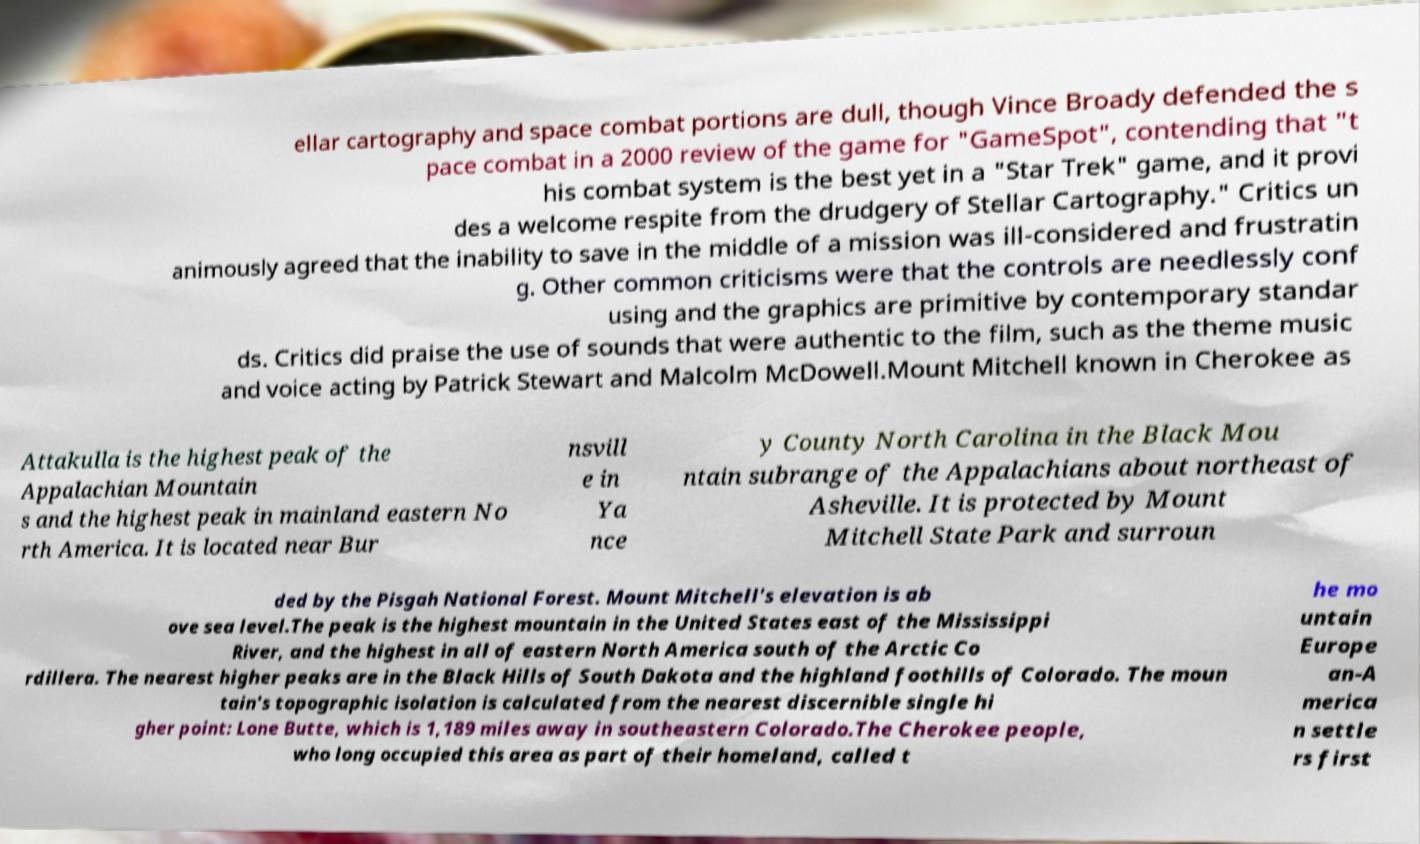Can you accurately transcribe the text from the provided image for me? ellar cartography and space combat portions are dull, though Vince Broady defended the s pace combat in a 2000 review of the game for "GameSpot", contending that "t his combat system is the best yet in a "Star Trek" game, and it provi des a welcome respite from the drudgery of Stellar Cartography." Critics un animously agreed that the inability to save in the middle of a mission was ill-considered and frustratin g. Other common criticisms were that the controls are needlessly conf using and the graphics are primitive by contemporary standar ds. Critics did praise the use of sounds that were authentic to the film, such as the theme music and voice acting by Patrick Stewart and Malcolm McDowell.Mount Mitchell known in Cherokee as Attakulla is the highest peak of the Appalachian Mountain s and the highest peak in mainland eastern No rth America. It is located near Bur nsvill e in Ya nce y County North Carolina in the Black Mou ntain subrange of the Appalachians about northeast of Asheville. It is protected by Mount Mitchell State Park and surroun ded by the Pisgah National Forest. Mount Mitchell's elevation is ab ove sea level.The peak is the highest mountain in the United States east of the Mississippi River, and the highest in all of eastern North America south of the Arctic Co rdillera. The nearest higher peaks are in the Black Hills of South Dakota and the highland foothills of Colorado. The moun tain's topographic isolation is calculated from the nearest discernible single hi gher point: Lone Butte, which is 1,189 miles away in southeastern Colorado.The Cherokee people, who long occupied this area as part of their homeland, called t he mo untain Europe an-A merica n settle rs first 